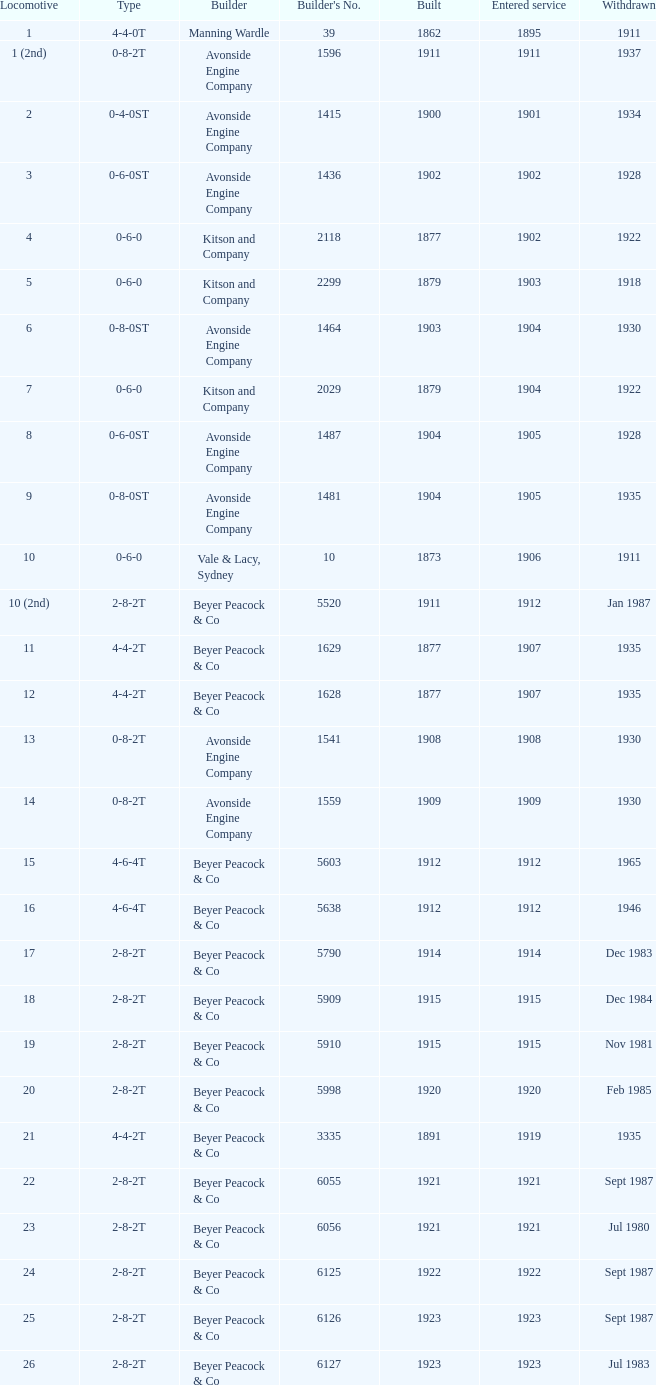Which locomotive had a 2-8-2t type, entered service year prior to 1915, and which was built after 1911? 17.0. 